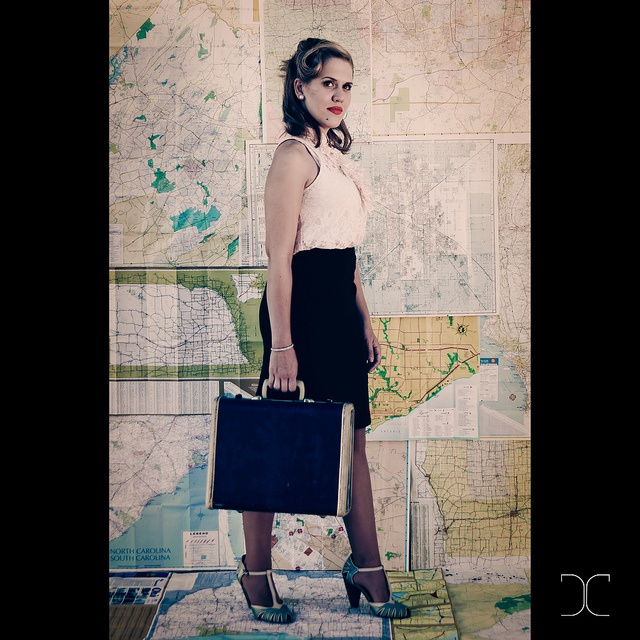Describe the objects in this image and their specific colors. I can see people in black, darkgray, tan, and lightgray tones, suitcase in black, darkgray, gray, and navy tones, and handbag in black, darkgray, and gray tones in this image. 